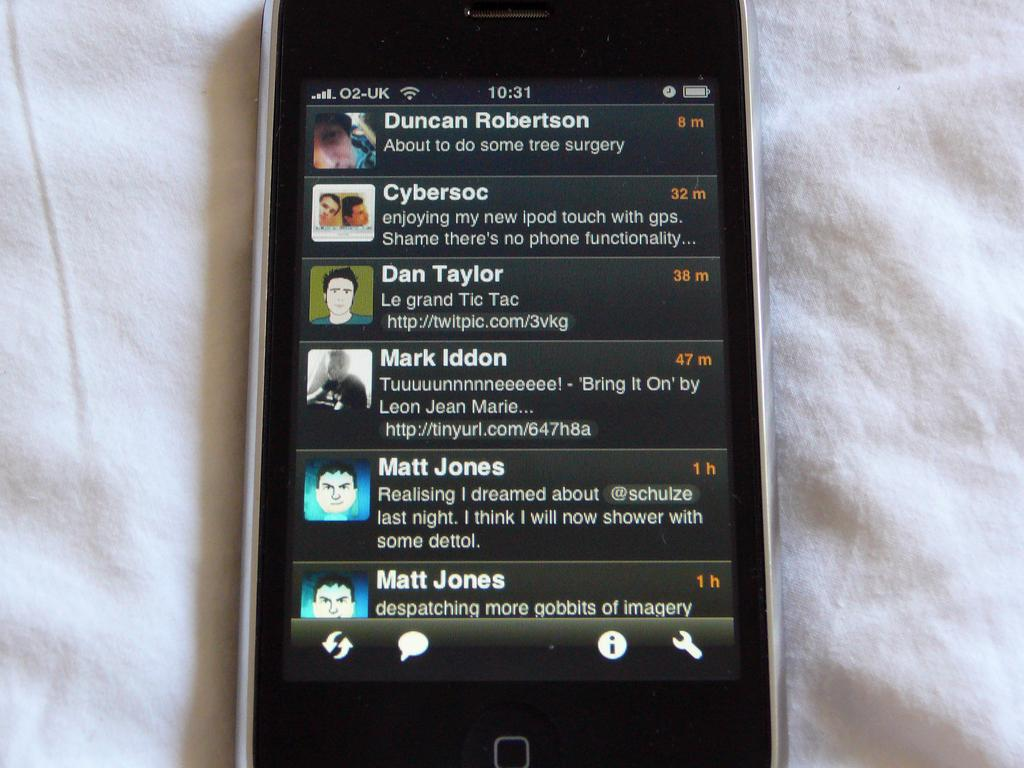Provide a one-sentence caption for the provided image. a phone that has the name Duncan Robertson on it. 